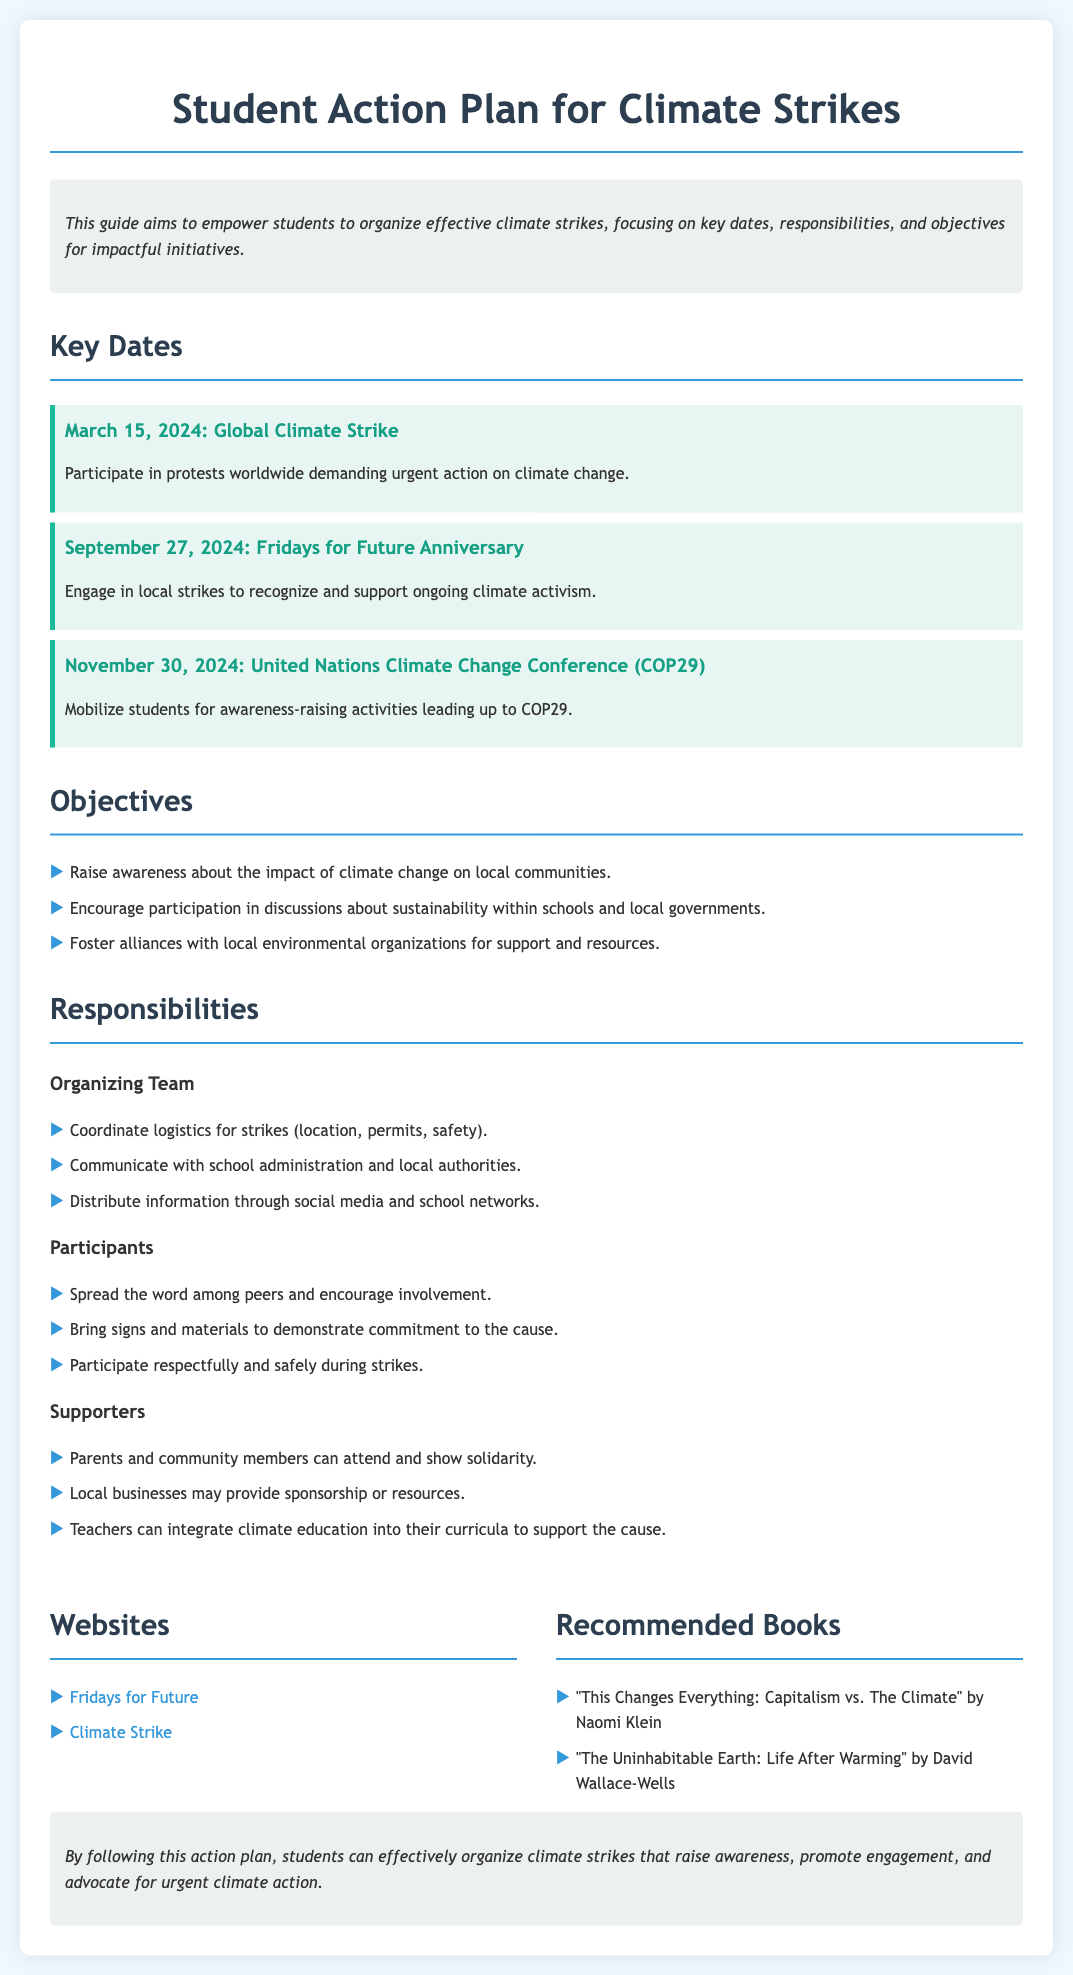What is the title of the document? The title appears at the top of the document, indicating the subject matter it covers.
Answer: Student Action Plan for Climate Strikes When is the Global Climate Strike scheduled? The date for the Global Climate Strike is highlighted in the key dates section of the document.
Answer: March 15, 2024 What is one objective mentioned in the document? The objectives are listed in a bullet format, outlining the goals of the climate strikes.
Answer: Raise awareness about the impact of climate change on local communities Who is responsible for coordinating logistics for strikes? The responsibilities section specifies the organizing team and their tasks.
Answer: Organizing Team What is the date for the Fridays for Future Anniversary? This date is noted in the key dates section, which lists important events related to the climate strikes.
Answer: September 27, 2024 How many recommended books are listed in the resources section? The number of items under the recommended books category indicates the variety of resources available.
Answer: 2 What type of solidarity can parents and community members show? This type of support is mentioned in relation to the responsibilities of supporters.
Answer: Attend and show solidarity What should participants bring to demonstrate their commitment? This information includes a specific action participants are encouraged to take during the strikes.
Answer: Signs and materials 